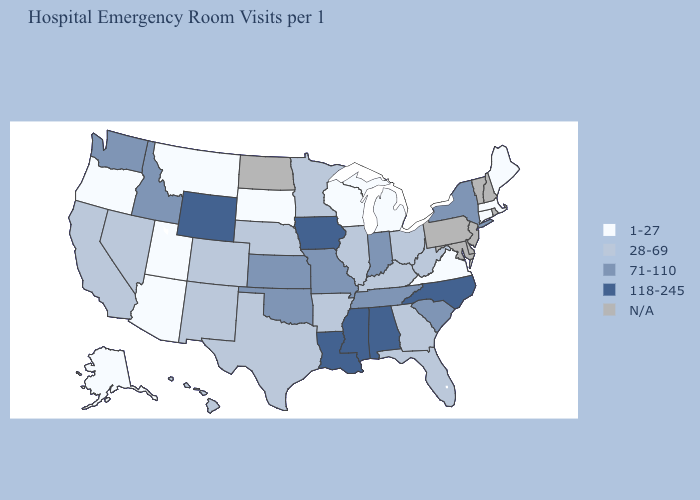Name the states that have a value in the range 71-110?
Answer briefly. Idaho, Indiana, Kansas, Missouri, New York, Oklahoma, South Carolina, Tennessee, Washington. Among the states that border Wisconsin , does Iowa have the highest value?
Write a very short answer. Yes. Does New York have the lowest value in the USA?
Keep it brief. No. Name the states that have a value in the range 28-69?
Concise answer only. Arkansas, California, Colorado, Florida, Georgia, Hawaii, Illinois, Kentucky, Minnesota, Nebraska, Nevada, New Mexico, Ohio, Texas, West Virginia. What is the value of Delaware?
Answer briefly. N/A. Is the legend a continuous bar?
Keep it brief. No. What is the value of South Dakota?
Give a very brief answer. 1-27. What is the value of Indiana?
Short answer required. 71-110. What is the lowest value in states that border Vermont?
Keep it brief. 1-27. Name the states that have a value in the range 118-245?
Quick response, please. Alabama, Iowa, Louisiana, Mississippi, North Carolina, Wyoming. What is the highest value in states that border Iowa?
Write a very short answer. 71-110. Does the first symbol in the legend represent the smallest category?
Write a very short answer. Yes. What is the highest value in the Northeast ?
Be succinct. 71-110. What is the value of Idaho?
Write a very short answer. 71-110. What is the lowest value in the USA?
Concise answer only. 1-27. 